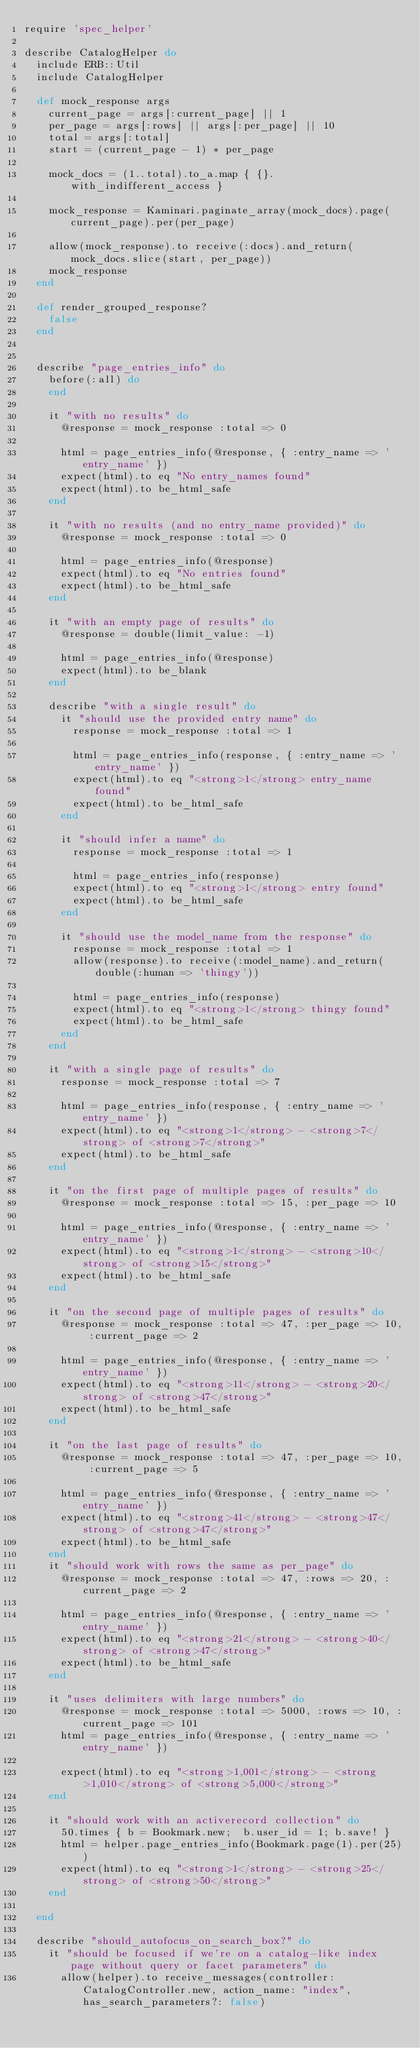Convert code to text. <code><loc_0><loc_0><loc_500><loc_500><_Ruby_>require 'spec_helper'

describe CatalogHelper do
  include ERB::Util
  include CatalogHelper

  def mock_response args
    current_page = args[:current_page] || 1
    per_page = args[:rows] || args[:per_page] || 10
    total = args[:total]
    start = (current_page - 1) * per_page

    mock_docs = (1..total).to_a.map { {}.with_indifferent_access }

    mock_response = Kaminari.paginate_array(mock_docs).page(current_page).per(per_page)

    allow(mock_response).to receive(:docs).and_return(mock_docs.slice(start, per_page))
    mock_response
  end

  def render_grouped_response?
    false
  end


  describe "page_entries_info" do
    before(:all) do
    end

    it "with no results" do
      @response = mock_response :total => 0

      html = page_entries_info(@response, { :entry_name => 'entry_name' })
      expect(html).to eq "No entry_names found"
      expect(html).to be_html_safe
    end

    it "with no results (and no entry_name provided)" do
      @response = mock_response :total => 0

      html = page_entries_info(@response)
      expect(html).to eq "No entries found"
      expect(html).to be_html_safe
    end

    it "with an empty page of results" do
      @response = double(limit_value: -1)

      html = page_entries_info(@response)
      expect(html).to be_blank
    end

    describe "with a single result" do
      it "should use the provided entry name" do
        response = mock_response :total => 1

        html = page_entries_info(response, { :entry_name => 'entry_name' })
        expect(html).to eq "<strong>1</strong> entry_name found"
        expect(html).to be_html_safe
      end

      it "should infer a name" do
        response = mock_response :total => 1

        html = page_entries_info(response)
        expect(html).to eq "<strong>1</strong> entry found"
        expect(html).to be_html_safe
      end

      it "should use the model_name from the response" do
        response = mock_response :total => 1
        allow(response).to receive(:model_name).and_return(double(:human => 'thingy'))

        html = page_entries_info(response)
        expect(html).to eq "<strong>1</strong> thingy found"
        expect(html).to be_html_safe
      end
    end

    it "with a single page of results" do
      response = mock_response :total => 7

      html = page_entries_info(response, { :entry_name => 'entry_name' })
      expect(html).to eq "<strong>1</strong> - <strong>7</strong> of <strong>7</strong>"
      expect(html).to be_html_safe
    end

    it "on the first page of multiple pages of results" do
      @response = mock_response :total => 15, :per_page => 10

      html = page_entries_info(@response, { :entry_name => 'entry_name' })
      expect(html).to eq "<strong>1</strong> - <strong>10</strong> of <strong>15</strong>"
      expect(html).to be_html_safe
    end

    it "on the second page of multiple pages of results" do
      @response = mock_response :total => 47, :per_page => 10, :current_page => 2

      html = page_entries_info(@response, { :entry_name => 'entry_name' })
      expect(html).to eq "<strong>11</strong> - <strong>20</strong> of <strong>47</strong>"
      expect(html).to be_html_safe
    end

    it "on the last page of results" do
      @response = mock_response :total => 47, :per_page => 10, :current_page => 5

      html = page_entries_info(@response, { :entry_name => 'entry_name' })
      expect(html).to eq "<strong>41</strong> - <strong>47</strong> of <strong>47</strong>"
      expect(html).to be_html_safe
    end
    it "should work with rows the same as per_page" do
      @response = mock_response :total => 47, :rows => 20, :current_page => 2

      html = page_entries_info(@response, { :entry_name => 'entry_name' })
      expect(html).to eq "<strong>21</strong> - <strong>40</strong> of <strong>47</strong>"
      expect(html).to be_html_safe
    end

    it "uses delimiters with large numbers" do
      @response = mock_response :total => 5000, :rows => 10, :current_page => 101
      html = page_entries_info(@response, { :entry_name => 'entry_name' })

      expect(html).to eq "<strong>1,001</strong> - <strong>1,010</strong> of <strong>5,000</strong>"
    end

    it "should work with an activerecord collection" do
      50.times { b = Bookmark.new;  b.user_id = 1; b.save! }
      html = helper.page_entries_info(Bookmark.page(1).per(25))
      expect(html).to eq "<strong>1</strong> - <strong>25</strong> of <strong>50</strong>"
    end

  end

  describe "should_autofocus_on_search_box?" do
    it "should be focused if we're on a catalog-like index page without query or facet parameters" do
      allow(helper).to receive_messages(controller: CatalogController.new, action_name: "index", has_search_parameters?: false)</code> 